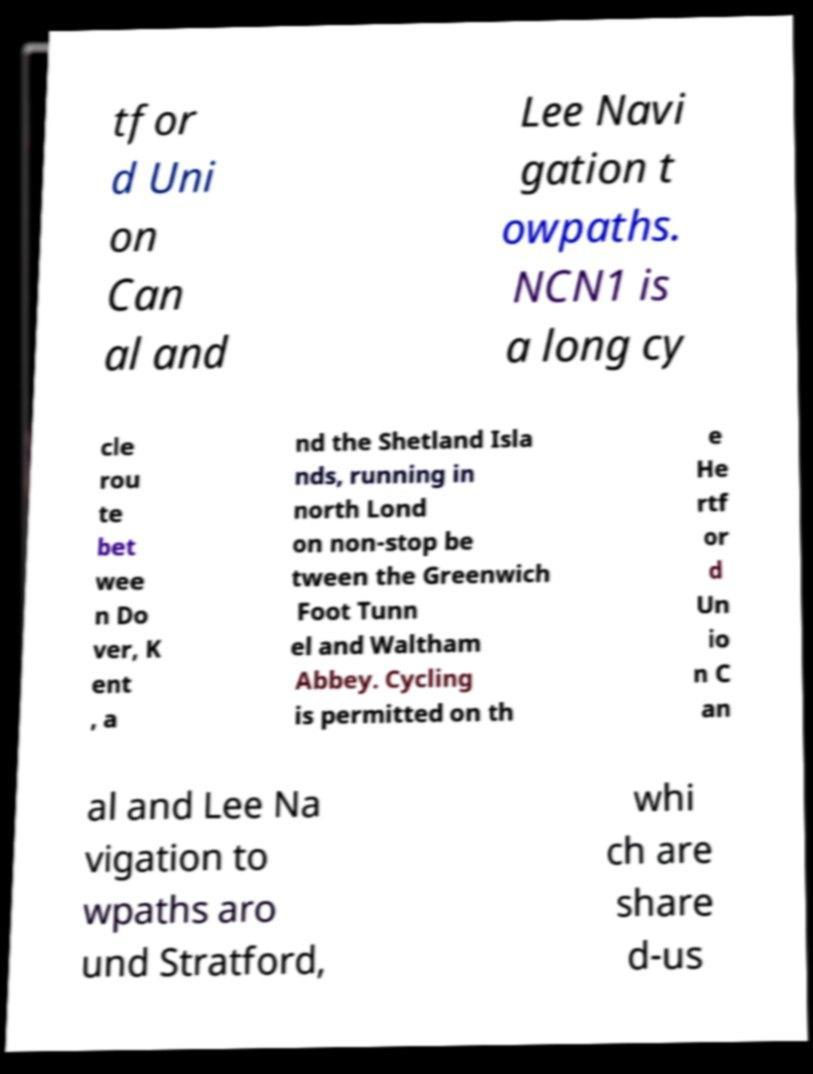There's text embedded in this image that I need extracted. Can you transcribe it verbatim? tfor d Uni on Can al and Lee Navi gation t owpaths. NCN1 is a long cy cle rou te bet wee n Do ver, K ent , a nd the Shetland Isla nds, running in north Lond on non-stop be tween the Greenwich Foot Tunn el and Waltham Abbey. Cycling is permitted on th e He rtf or d Un io n C an al and Lee Na vigation to wpaths aro und Stratford, whi ch are share d-us 